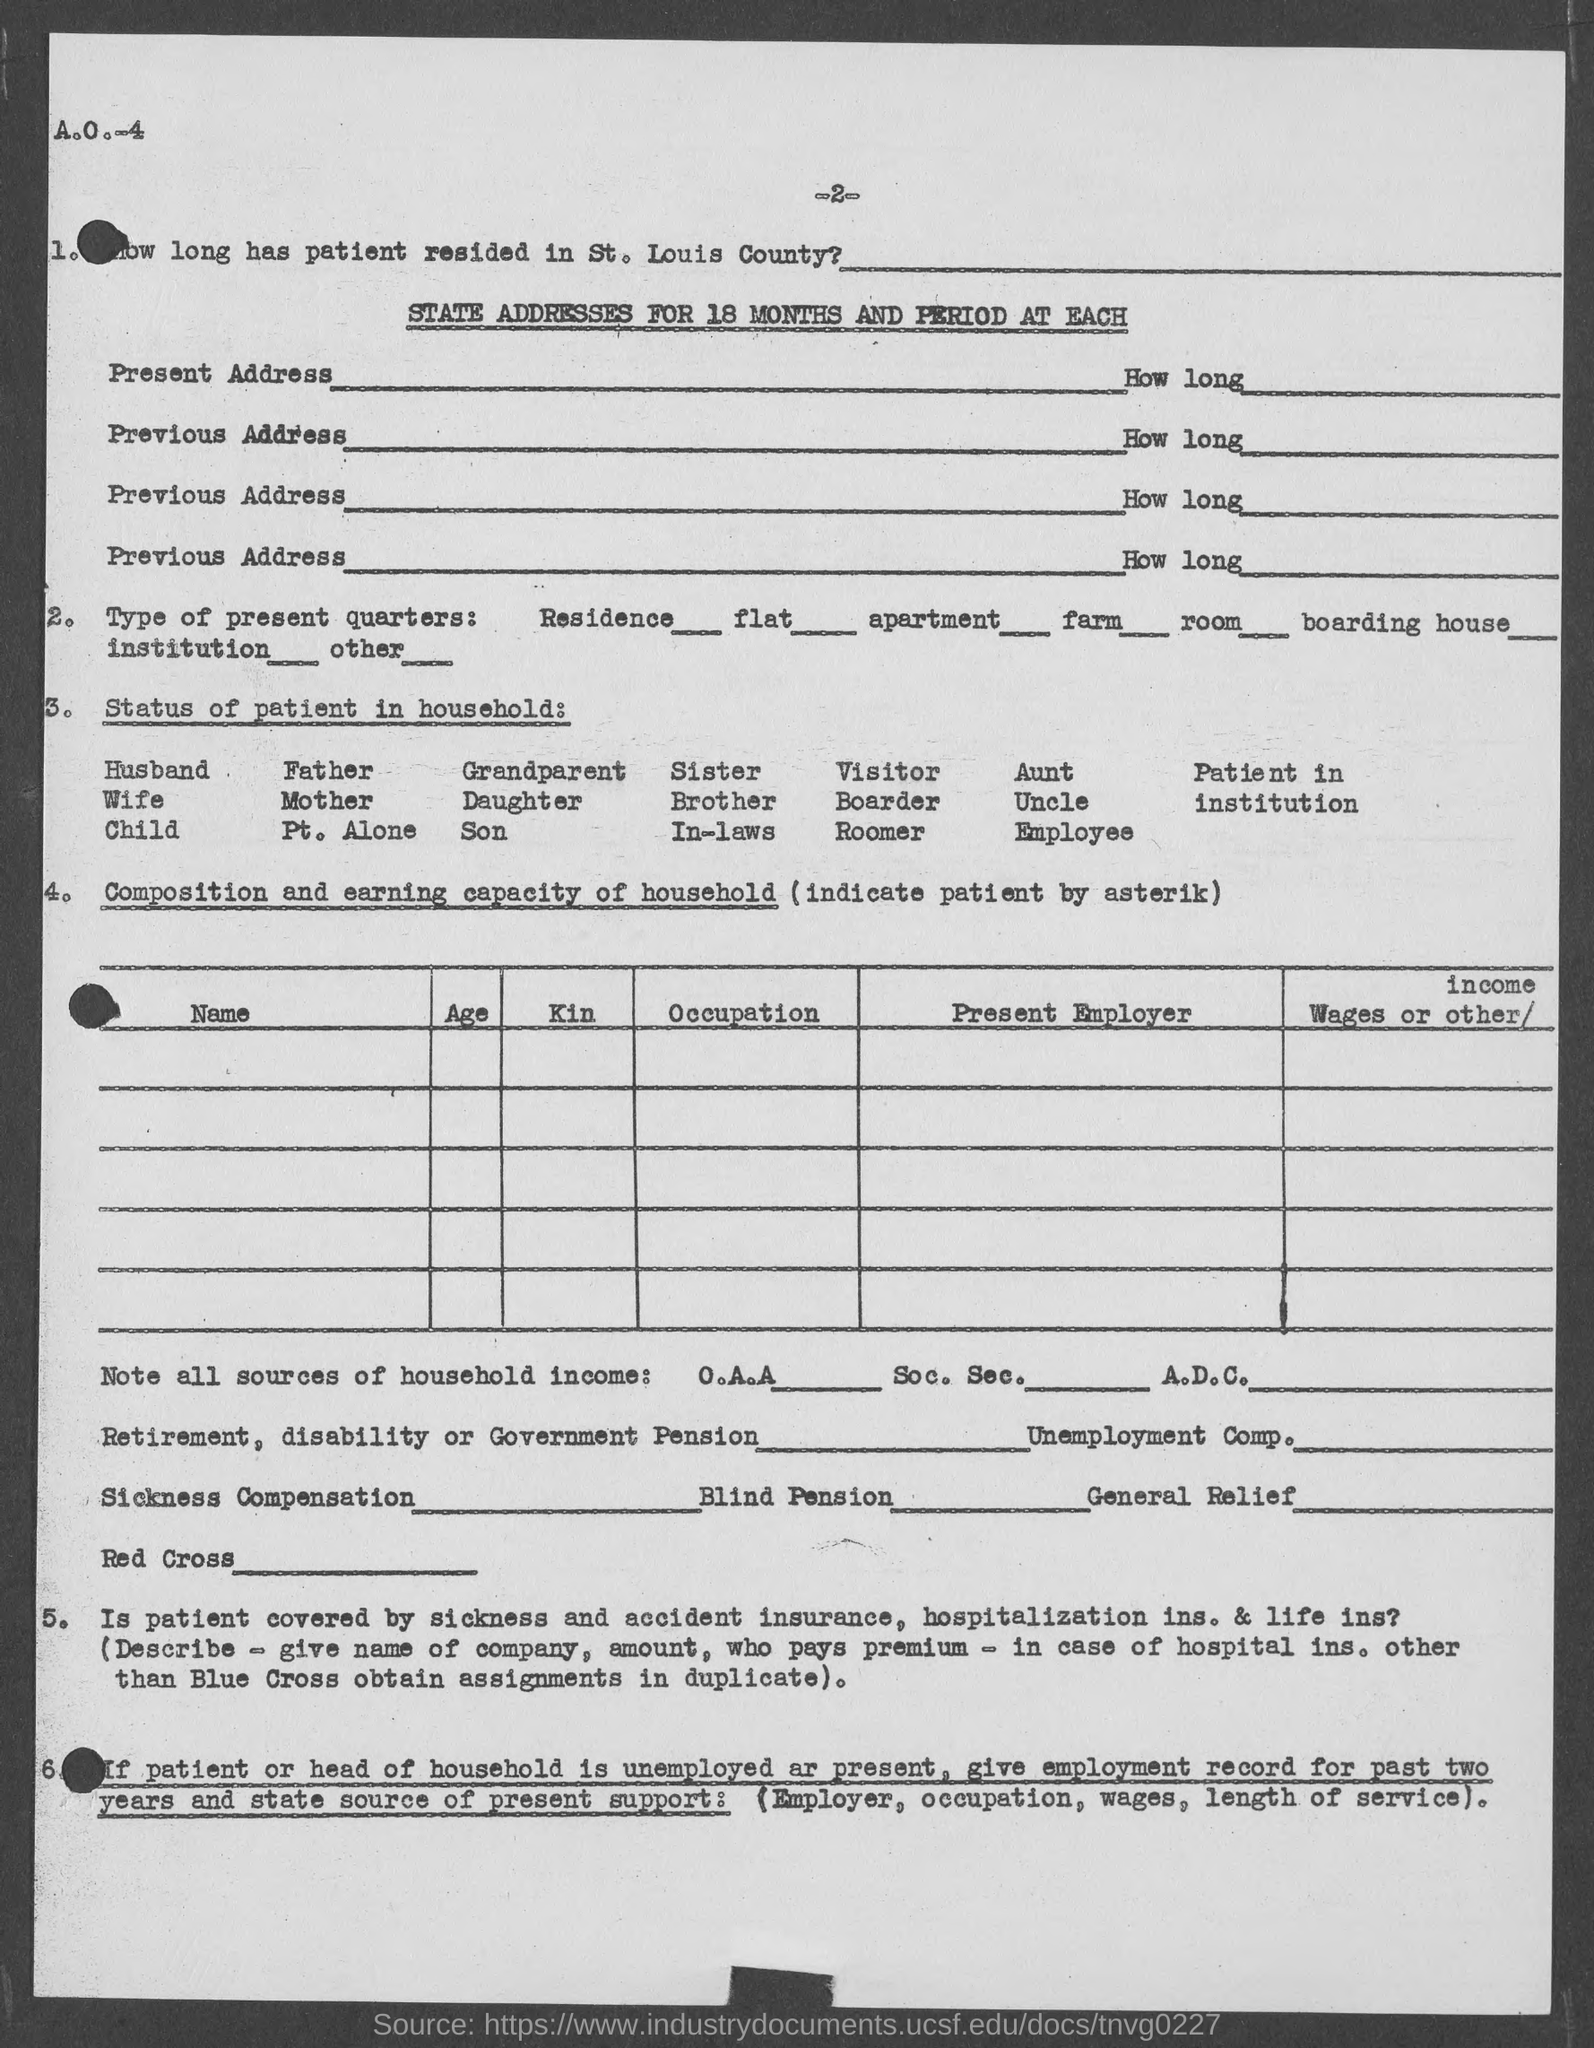What is the number at top of the page?
Keep it short and to the point. -2-. 